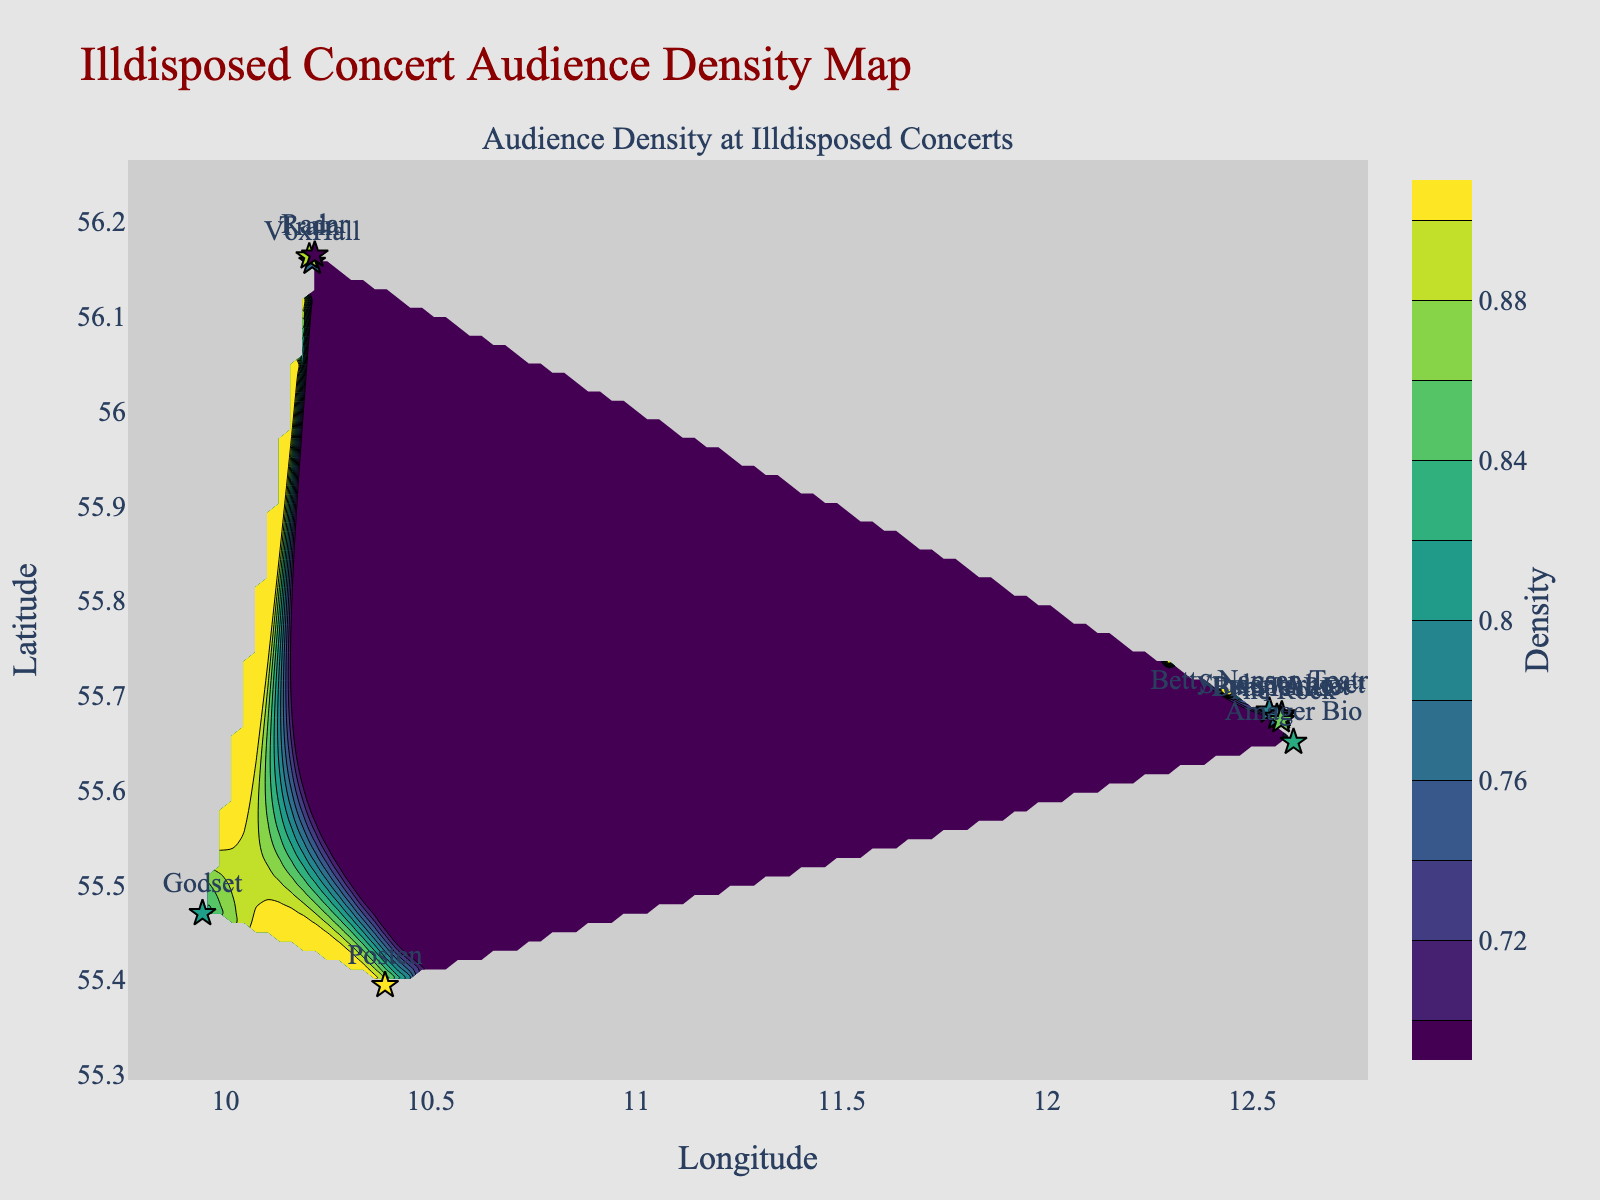What's the title of the figure? The title is usually found at the top of the figure. For this plot, it is "Illdisposed Concert Audience Density Map."
Answer: Illdisposed Concert Audience Density Map What are the axis labels? The x-axis is labeled "Longitude," and the y-axis is labeled "Latitude." These labels help to identify the geographic coordinates of the venues.
Answer: Longitude, Latitude What is the venue with the highest audience density? By looking at the data points on the scatter plot, the venue labeled "Posten" has the highest density value of 0.90.
Answer: Posten Which venue has the lowest audience density? From the scatter plot data, "Radar" has the lowest density value of 0.72.
Answer: Radar How many venues have an audience density of 0.80 or higher? By analyzing the density values in the scatter plot, the venues with densities of 0.80 or higher are Pumpehuset (0.85), Betty Nansen Teatret (0.80), Train (0.88), Amager Bio (0.83), Posten (0.90), Godset (0.82), The Rock (0.86). There are 7 such venues in total.
Answer: 7 Which venues have a density value between 0.75 and 0.85? From the scatter plot, the venues with density values between 0.75 and 0.85 are VoxHall (0.78), Betty Nansen Teatret (0.80), Amager Bio (0.83), Studenterhuset (0.75), Godset (0.82), and BASTARD (0.79).
Answer: VoxHall, Betty Nansen Teatret, Amager Bio, Studenterhuset, Godset, BASTARD Is there any venue that has the same latitude but different longitude compared with Train? If yes, what is its name? Train's latitude is 56.1629. Radar has a very close latitude of 56.1648, which is enough for the visual interpretation. Since Radar and Train share similar latitude but different longitudes, Radar is the venue.
Answer: Radar What contour range of audience density is visualized in the plot? The contour plot visualizes audience density with contour lines starting from 0.7 to 0.9. This can be inferred from the color bar and the density values shown.
Answer: 0.7 to 0.9 Which venue is furthest south? By looking at the latitude values on the y-axis, "Amager Bio" at latitude 55.6507 is the furthest south.
Answer: Amager Bio 